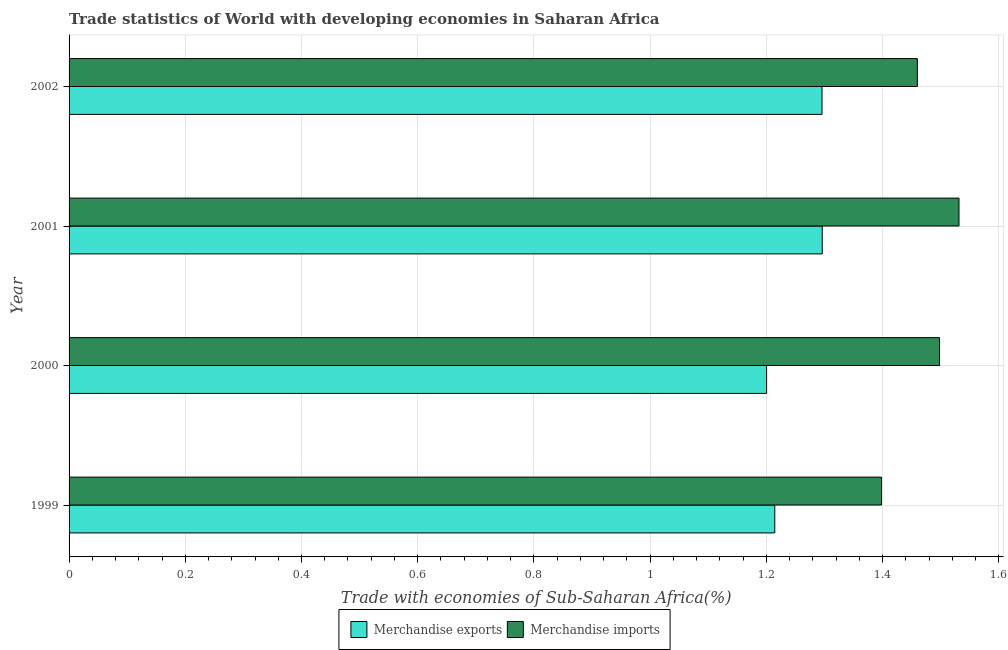Are the number of bars per tick equal to the number of legend labels?
Your answer should be compact. Yes. Are the number of bars on each tick of the Y-axis equal?
Your answer should be compact. Yes. How many bars are there on the 1st tick from the top?
Offer a terse response. 2. What is the label of the 1st group of bars from the top?
Offer a very short reply. 2002. What is the merchandise exports in 2001?
Keep it short and to the point. 1.3. Across all years, what is the maximum merchandise imports?
Provide a succinct answer. 1.53. Across all years, what is the minimum merchandise exports?
Make the answer very short. 1.2. In which year was the merchandise exports maximum?
Your answer should be compact. 2001. What is the total merchandise exports in the graph?
Your answer should be compact. 5.01. What is the difference between the merchandise exports in 2000 and that in 2001?
Offer a very short reply. -0.1. What is the difference between the merchandise imports in 1999 and the merchandise exports in 2000?
Ensure brevity in your answer.  0.2. What is the average merchandise exports per year?
Make the answer very short. 1.25. In the year 1999, what is the difference between the merchandise imports and merchandise exports?
Offer a very short reply. 0.18. In how many years, is the merchandise imports greater than 0.8 %?
Ensure brevity in your answer.  4. What is the ratio of the merchandise imports in 2001 to that in 2002?
Provide a short and direct response. 1.05. Is the merchandise imports in 2000 less than that in 2001?
Your response must be concise. Yes. Is the difference between the merchandise exports in 1999 and 2001 greater than the difference between the merchandise imports in 1999 and 2001?
Offer a terse response. Yes. What is the difference between the highest and the second highest merchandise imports?
Provide a succinct answer. 0.03. What is the difference between the highest and the lowest merchandise imports?
Your answer should be compact. 0.13. In how many years, is the merchandise exports greater than the average merchandise exports taken over all years?
Offer a very short reply. 2. Is the sum of the merchandise imports in 2000 and 2001 greater than the maximum merchandise exports across all years?
Provide a short and direct response. Yes. What does the 1st bar from the top in 1999 represents?
Offer a very short reply. Merchandise imports. What does the 2nd bar from the bottom in 2000 represents?
Offer a very short reply. Merchandise imports. How many bars are there?
Your response must be concise. 8. Are all the bars in the graph horizontal?
Offer a very short reply. Yes. How many years are there in the graph?
Your response must be concise. 4. Where does the legend appear in the graph?
Your answer should be very brief. Bottom center. What is the title of the graph?
Your answer should be very brief. Trade statistics of World with developing economies in Saharan Africa. What is the label or title of the X-axis?
Offer a terse response. Trade with economies of Sub-Saharan Africa(%). What is the Trade with economies of Sub-Saharan Africa(%) in Merchandise exports in 1999?
Make the answer very short. 1.21. What is the Trade with economies of Sub-Saharan Africa(%) in Merchandise imports in 1999?
Give a very brief answer. 1.4. What is the Trade with economies of Sub-Saharan Africa(%) in Merchandise exports in 2000?
Give a very brief answer. 1.2. What is the Trade with economies of Sub-Saharan Africa(%) in Merchandise imports in 2000?
Provide a short and direct response. 1.5. What is the Trade with economies of Sub-Saharan Africa(%) of Merchandise exports in 2001?
Give a very brief answer. 1.3. What is the Trade with economies of Sub-Saharan Africa(%) of Merchandise imports in 2001?
Offer a terse response. 1.53. What is the Trade with economies of Sub-Saharan Africa(%) in Merchandise exports in 2002?
Give a very brief answer. 1.3. What is the Trade with economies of Sub-Saharan Africa(%) in Merchandise imports in 2002?
Offer a terse response. 1.46. Across all years, what is the maximum Trade with economies of Sub-Saharan Africa(%) of Merchandise exports?
Make the answer very short. 1.3. Across all years, what is the maximum Trade with economies of Sub-Saharan Africa(%) of Merchandise imports?
Offer a terse response. 1.53. Across all years, what is the minimum Trade with economies of Sub-Saharan Africa(%) in Merchandise exports?
Ensure brevity in your answer.  1.2. Across all years, what is the minimum Trade with economies of Sub-Saharan Africa(%) of Merchandise imports?
Provide a succinct answer. 1.4. What is the total Trade with economies of Sub-Saharan Africa(%) of Merchandise exports in the graph?
Make the answer very short. 5.01. What is the total Trade with economies of Sub-Saharan Africa(%) of Merchandise imports in the graph?
Keep it short and to the point. 5.89. What is the difference between the Trade with economies of Sub-Saharan Africa(%) of Merchandise exports in 1999 and that in 2000?
Offer a terse response. 0.01. What is the difference between the Trade with economies of Sub-Saharan Africa(%) of Merchandise imports in 1999 and that in 2000?
Your answer should be very brief. -0.1. What is the difference between the Trade with economies of Sub-Saharan Africa(%) in Merchandise exports in 1999 and that in 2001?
Make the answer very short. -0.08. What is the difference between the Trade with economies of Sub-Saharan Africa(%) of Merchandise imports in 1999 and that in 2001?
Your response must be concise. -0.13. What is the difference between the Trade with economies of Sub-Saharan Africa(%) in Merchandise exports in 1999 and that in 2002?
Offer a terse response. -0.08. What is the difference between the Trade with economies of Sub-Saharan Africa(%) of Merchandise imports in 1999 and that in 2002?
Provide a succinct answer. -0.06. What is the difference between the Trade with economies of Sub-Saharan Africa(%) in Merchandise exports in 2000 and that in 2001?
Your response must be concise. -0.1. What is the difference between the Trade with economies of Sub-Saharan Africa(%) in Merchandise imports in 2000 and that in 2001?
Ensure brevity in your answer.  -0.03. What is the difference between the Trade with economies of Sub-Saharan Africa(%) of Merchandise exports in 2000 and that in 2002?
Your answer should be compact. -0.1. What is the difference between the Trade with economies of Sub-Saharan Africa(%) of Merchandise imports in 2000 and that in 2002?
Your response must be concise. 0.04. What is the difference between the Trade with economies of Sub-Saharan Africa(%) in Merchandise exports in 2001 and that in 2002?
Ensure brevity in your answer.  0. What is the difference between the Trade with economies of Sub-Saharan Africa(%) in Merchandise imports in 2001 and that in 2002?
Make the answer very short. 0.07. What is the difference between the Trade with economies of Sub-Saharan Africa(%) of Merchandise exports in 1999 and the Trade with economies of Sub-Saharan Africa(%) of Merchandise imports in 2000?
Your answer should be very brief. -0.28. What is the difference between the Trade with economies of Sub-Saharan Africa(%) in Merchandise exports in 1999 and the Trade with economies of Sub-Saharan Africa(%) in Merchandise imports in 2001?
Offer a terse response. -0.32. What is the difference between the Trade with economies of Sub-Saharan Africa(%) in Merchandise exports in 1999 and the Trade with economies of Sub-Saharan Africa(%) in Merchandise imports in 2002?
Offer a terse response. -0.25. What is the difference between the Trade with economies of Sub-Saharan Africa(%) in Merchandise exports in 2000 and the Trade with economies of Sub-Saharan Africa(%) in Merchandise imports in 2001?
Ensure brevity in your answer.  -0.33. What is the difference between the Trade with economies of Sub-Saharan Africa(%) of Merchandise exports in 2000 and the Trade with economies of Sub-Saharan Africa(%) of Merchandise imports in 2002?
Your answer should be compact. -0.26. What is the difference between the Trade with economies of Sub-Saharan Africa(%) in Merchandise exports in 2001 and the Trade with economies of Sub-Saharan Africa(%) in Merchandise imports in 2002?
Offer a terse response. -0.16. What is the average Trade with economies of Sub-Saharan Africa(%) in Merchandise exports per year?
Keep it short and to the point. 1.25. What is the average Trade with economies of Sub-Saharan Africa(%) in Merchandise imports per year?
Keep it short and to the point. 1.47. In the year 1999, what is the difference between the Trade with economies of Sub-Saharan Africa(%) of Merchandise exports and Trade with economies of Sub-Saharan Africa(%) of Merchandise imports?
Make the answer very short. -0.18. In the year 2000, what is the difference between the Trade with economies of Sub-Saharan Africa(%) of Merchandise exports and Trade with economies of Sub-Saharan Africa(%) of Merchandise imports?
Your answer should be compact. -0.3. In the year 2001, what is the difference between the Trade with economies of Sub-Saharan Africa(%) of Merchandise exports and Trade with economies of Sub-Saharan Africa(%) of Merchandise imports?
Your response must be concise. -0.24. In the year 2002, what is the difference between the Trade with economies of Sub-Saharan Africa(%) in Merchandise exports and Trade with economies of Sub-Saharan Africa(%) in Merchandise imports?
Give a very brief answer. -0.16. What is the ratio of the Trade with economies of Sub-Saharan Africa(%) of Merchandise exports in 1999 to that in 2000?
Your answer should be very brief. 1.01. What is the ratio of the Trade with economies of Sub-Saharan Africa(%) in Merchandise imports in 1999 to that in 2000?
Keep it short and to the point. 0.93. What is the ratio of the Trade with economies of Sub-Saharan Africa(%) of Merchandise exports in 1999 to that in 2001?
Your answer should be compact. 0.94. What is the ratio of the Trade with economies of Sub-Saharan Africa(%) in Merchandise imports in 1999 to that in 2001?
Ensure brevity in your answer.  0.91. What is the ratio of the Trade with economies of Sub-Saharan Africa(%) of Merchandise exports in 1999 to that in 2002?
Your response must be concise. 0.94. What is the ratio of the Trade with economies of Sub-Saharan Africa(%) of Merchandise imports in 1999 to that in 2002?
Make the answer very short. 0.96. What is the ratio of the Trade with economies of Sub-Saharan Africa(%) in Merchandise exports in 2000 to that in 2001?
Provide a short and direct response. 0.93. What is the ratio of the Trade with economies of Sub-Saharan Africa(%) in Merchandise imports in 2000 to that in 2001?
Your response must be concise. 0.98. What is the ratio of the Trade with economies of Sub-Saharan Africa(%) of Merchandise exports in 2000 to that in 2002?
Keep it short and to the point. 0.93. What is the ratio of the Trade with economies of Sub-Saharan Africa(%) of Merchandise imports in 2000 to that in 2002?
Keep it short and to the point. 1.03. What is the ratio of the Trade with economies of Sub-Saharan Africa(%) in Merchandise exports in 2001 to that in 2002?
Your answer should be very brief. 1. What is the ratio of the Trade with economies of Sub-Saharan Africa(%) in Merchandise imports in 2001 to that in 2002?
Offer a terse response. 1.05. What is the difference between the highest and the second highest Trade with economies of Sub-Saharan Africa(%) in Merchandise exports?
Provide a short and direct response. 0. What is the difference between the highest and the second highest Trade with economies of Sub-Saharan Africa(%) in Merchandise imports?
Provide a succinct answer. 0.03. What is the difference between the highest and the lowest Trade with economies of Sub-Saharan Africa(%) in Merchandise exports?
Make the answer very short. 0.1. What is the difference between the highest and the lowest Trade with economies of Sub-Saharan Africa(%) in Merchandise imports?
Provide a short and direct response. 0.13. 